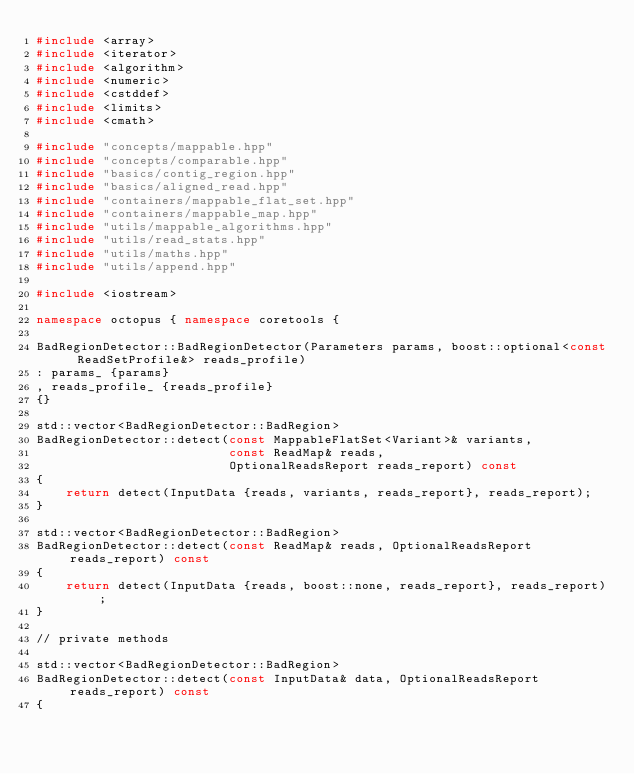<code> <loc_0><loc_0><loc_500><loc_500><_C++_>#include <array>
#include <iterator>
#include <algorithm>
#include <numeric>
#include <cstddef>
#include <limits>
#include <cmath>

#include "concepts/mappable.hpp"
#include "concepts/comparable.hpp"
#include "basics/contig_region.hpp"
#include "basics/aligned_read.hpp"
#include "containers/mappable_flat_set.hpp"
#include "containers/mappable_map.hpp"
#include "utils/mappable_algorithms.hpp"
#include "utils/read_stats.hpp"
#include "utils/maths.hpp"
#include "utils/append.hpp"

#include <iostream>

namespace octopus { namespace coretools {

BadRegionDetector::BadRegionDetector(Parameters params, boost::optional<const ReadSetProfile&> reads_profile)
: params_ {params}
, reads_profile_ {reads_profile}
{}

std::vector<BadRegionDetector::BadRegion>
BadRegionDetector::detect(const MappableFlatSet<Variant>& variants,
                          const ReadMap& reads,
                          OptionalReadsReport reads_report) const
{
    return detect(InputData {reads, variants, reads_report}, reads_report);
}

std::vector<BadRegionDetector::BadRegion>
BadRegionDetector::detect(const ReadMap& reads, OptionalReadsReport reads_report) const
{
    return detect(InputData {reads, boost::none, reads_report}, reads_report);
}

// private methods

std::vector<BadRegionDetector::BadRegion>
BadRegionDetector::detect(const InputData& data, OptionalReadsReport reads_report) const
{</code> 